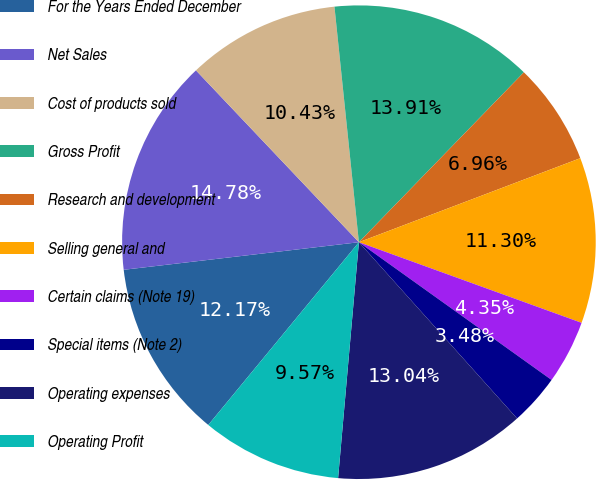Convert chart to OTSL. <chart><loc_0><loc_0><loc_500><loc_500><pie_chart><fcel>For the Years Ended December<fcel>Net Sales<fcel>Cost of products sold<fcel>Gross Profit<fcel>Research and development<fcel>Selling general and<fcel>Certain claims (Note 19)<fcel>Special items (Note 2)<fcel>Operating expenses<fcel>Operating Profit<nl><fcel>12.17%<fcel>14.78%<fcel>10.43%<fcel>13.91%<fcel>6.96%<fcel>11.3%<fcel>4.35%<fcel>3.48%<fcel>13.04%<fcel>9.57%<nl></chart> 